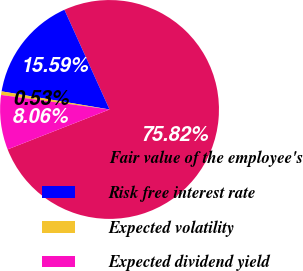Convert chart. <chart><loc_0><loc_0><loc_500><loc_500><pie_chart><fcel>Fair value of the employee's<fcel>Risk free interest rate<fcel>Expected volatility<fcel>Expected dividend yield<nl><fcel>75.83%<fcel>15.59%<fcel>0.53%<fcel>8.06%<nl></chart> 